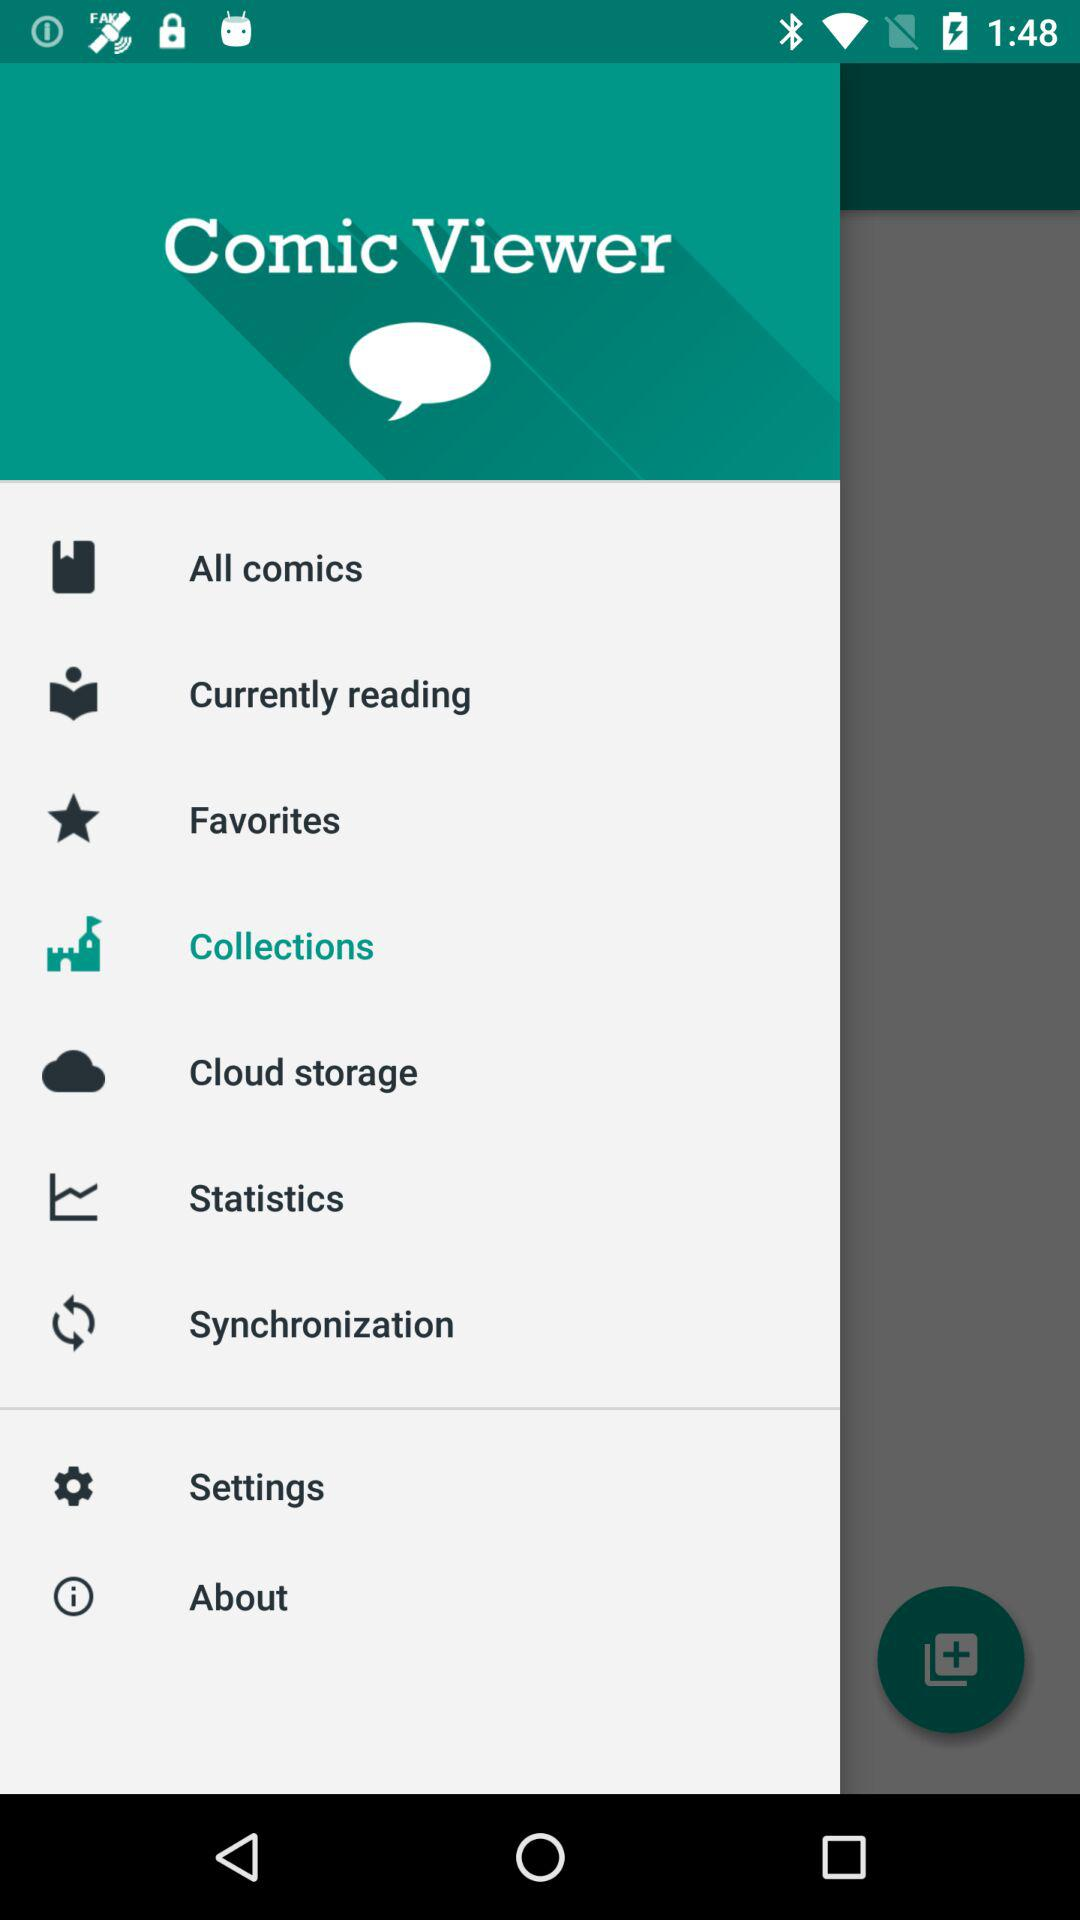Which option is selected? The selected option is "Collections". 